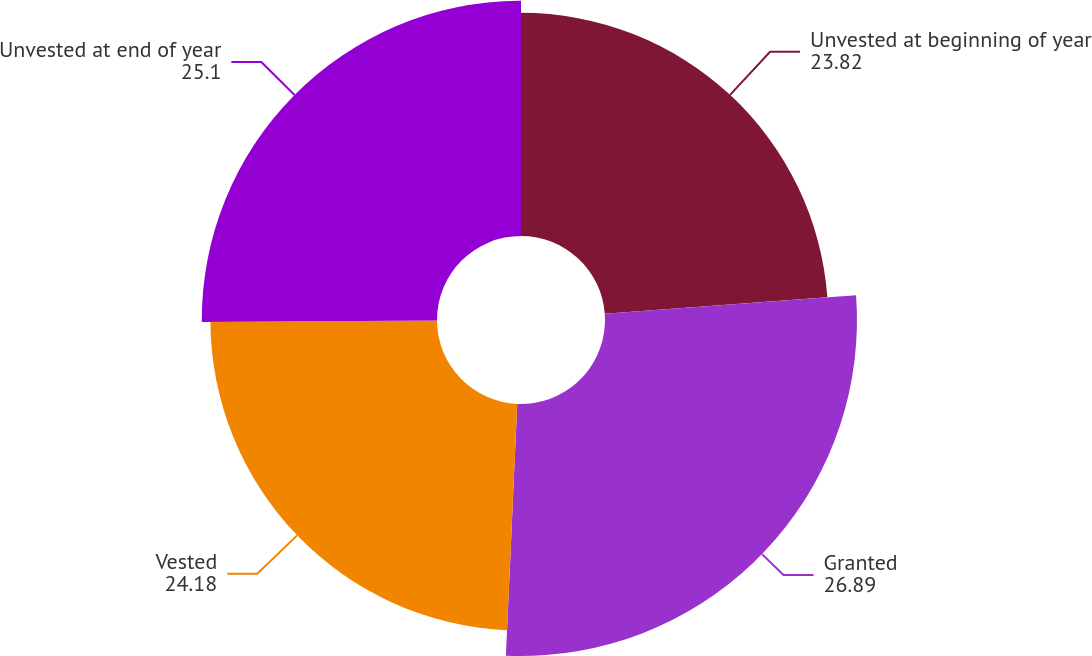Convert chart to OTSL. <chart><loc_0><loc_0><loc_500><loc_500><pie_chart><fcel>Unvested at beginning of year<fcel>Granted<fcel>Vested<fcel>Unvested at end of year<nl><fcel>23.82%<fcel>26.89%<fcel>24.18%<fcel>25.1%<nl></chart> 